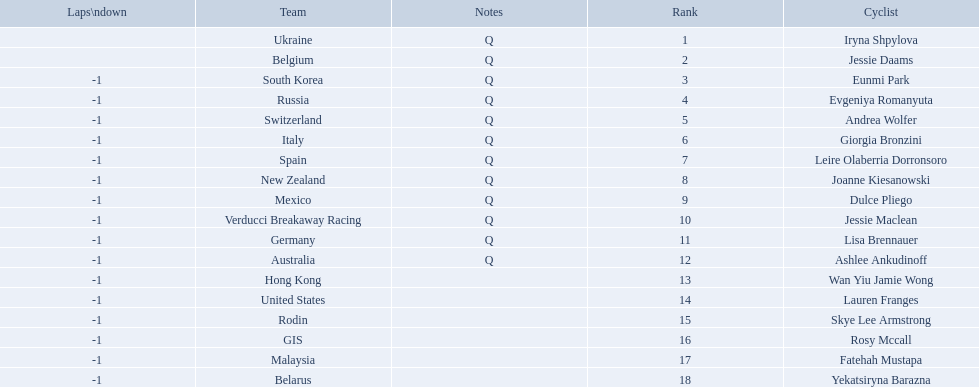Who are all of the cyclists in this race? Iryna Shpylova, Jessie Daams, Eunmi Park, Evgeniya Romanyuta, Andrea Wolfer, Giorgia Bronzini, Leire Olaberria Dorronsoro, Joanne Kiesanowski, Dulce Pliego, Jessie Maclean, Lisa Brennauer, Ashlee Ankudinoff, Wan Yiu Jamie Wong, Lauren Franges, Skye Lee Armstrong, Rosy Mccall, Fatehah Mustapa, Yekatsiryna Barazna. Of these, which one has the lowest numbered rank? Iryna Shpylova. 